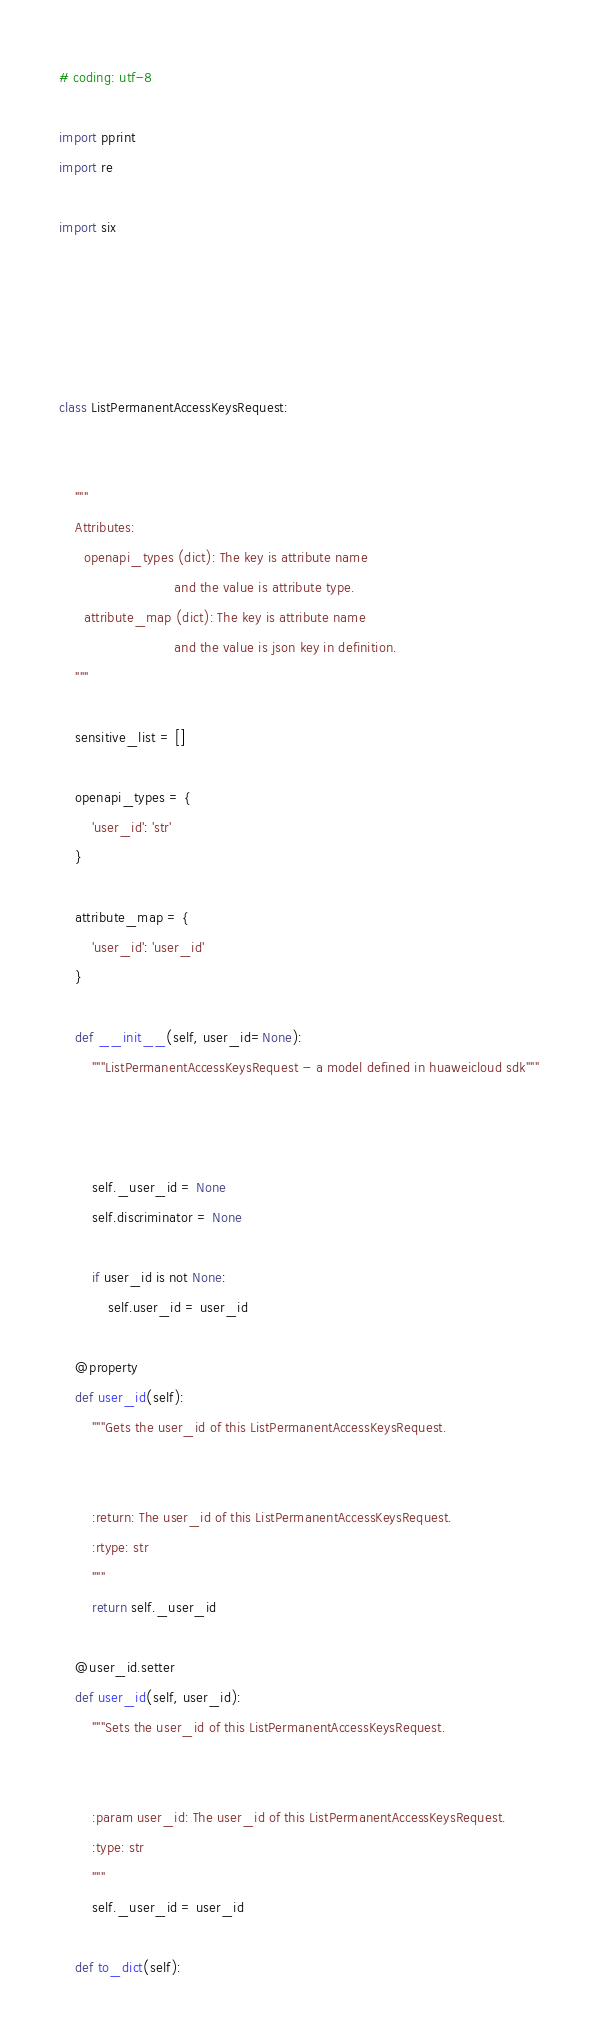<code> <loc_0><loc_0><loc_500><loc_500><_Python_># coding: utf-8

import pprint
import re

import six





class ListPermanentAccessKeysRequest:


    """
    Attributes:
      openapi_types (dict): The key is attribute name
                            and the value is attribute type.
      attribute_map (dict): The key is attribute name
                            and the value is json key in definition.
    """

    sensitive_list = []

    openapi_types = {
        'user_id': 'str'
    }

    attribute_map = {
        'user_id': 'user_id'
    }

    def __init__(self, user_id=None):
        """ListPermanentAccessKeysRequest - a model defined in huaweicloud sdk"""
        
        

        self._user_id = None
        self.discriminator = None

        if user_id is not None:
            self.user_id = user_id

    @property
    def user_id(self):
        """Gets the user_id of this ListPermanentAccessKeysRequest.


        :return: The user_id of this ListPermanentAccessKeysRequest.
        :rtype: str
        """
        return self._user_id

    @user_id.setter
    def user_id(self, user_id):
        """Sets the user_id of this ListPermanentAccessKeysRequest.


        :param user_id: The user_id of this ListPermanentAccessKeysRequest.
        :type: str
        """
        self._user_id = user_id

    def to_dict(self):</code> 